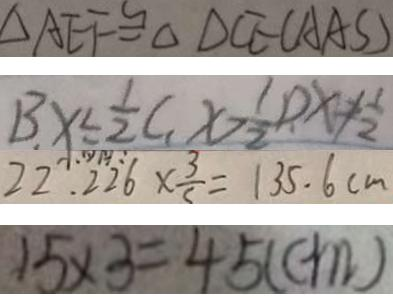Convert formula to latex. <formula><loc_0><loc_0><loc_500><loc_500>\Delta A E F \cong \Delta D C E ( A A S ) 
 B . x \leq \frac { 1 } { 2 } , C . x > \frac { 1 } { 2 } , D . x \neq \frac { 1 } { 2 } 
 2 2 . 2 2 6 \times \frac { 3 } { 5 } = 1 3 5 . 6 c m 
 1 5 \times 3 = 4 5 ( c m )</formula> 